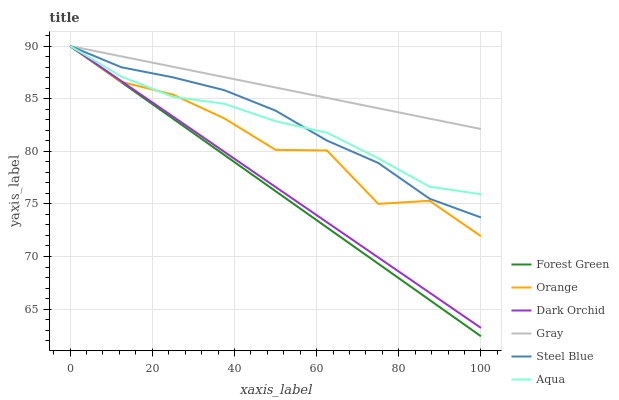Does Forest Green have the minimum area under the curve?
Answer yes or no. Yes. Does Gray have the maximum area under the curve?
Answer yes or no. Yes. Does Aqua have the minimum area under the curve?
Answer yes or no. No. Does Aqua have the maximum area under the curve?
Answer yes or no. No. Is Gray the smoothest?
Answer yes or no. Yes. Is Orange the roughest?
Answer yes or no. Yes. Is Aqua the smoothest?
Answer yes or no. No. Is Aqua the roughest?
Answer yes or no. No. Does Aqua have the lowest value?
Answer yes or no. No. 